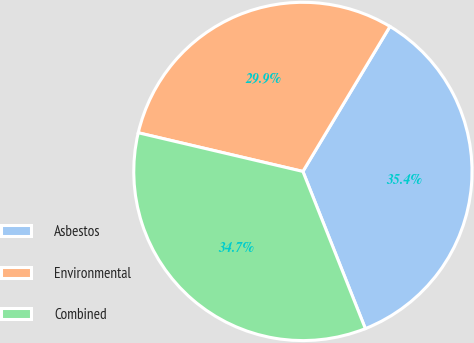<chart> <loc_0><loc_0><loc_500><loc_500><pie_chart><fcel>Asbestos<fcel>Environmental<fcel>Combined<nl><fcel>35.37%<fcel>29.93%<fcel>34.69%<nl></chart> 